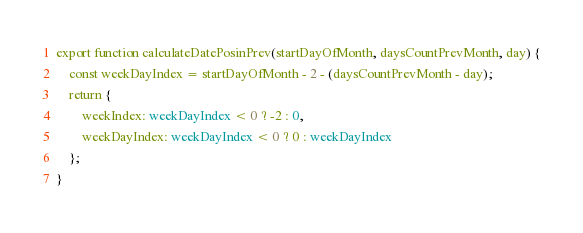Convert code to text. <code><loc_0><loc_0><loc_500><loc_500><_TypeScript_>export function calculateDatePosinPrev(startDayOfMonth, daysCountPrevMonth, day) {
    const weekDayIndex = startDayOfMonth - 2 - (daysCountPrevMonth - day);
    return {
        weekIndex: weekDayIndex < 0 ? -2 : 0,
        weekDayIndex: weekDayIndex < 0 ? 0 : weekDayIndex
    };
}
</code> 